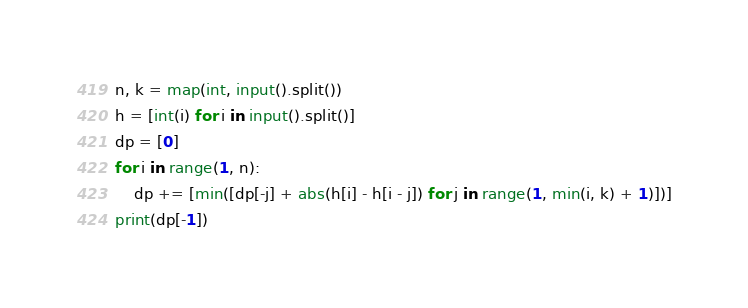<code> <loc_0><loc_0><loc_500><loc_500><_Python_>n, k = map(int, input().split())
h = [int(i) for i in input().split()]
dp = [0]
for i in range(1, n):
    dp += [min([dp[-j] + abs(h[i] - h[i - j]) for j in range(1, min(i, k) + 1)])]
print(dp[-1])</code> 